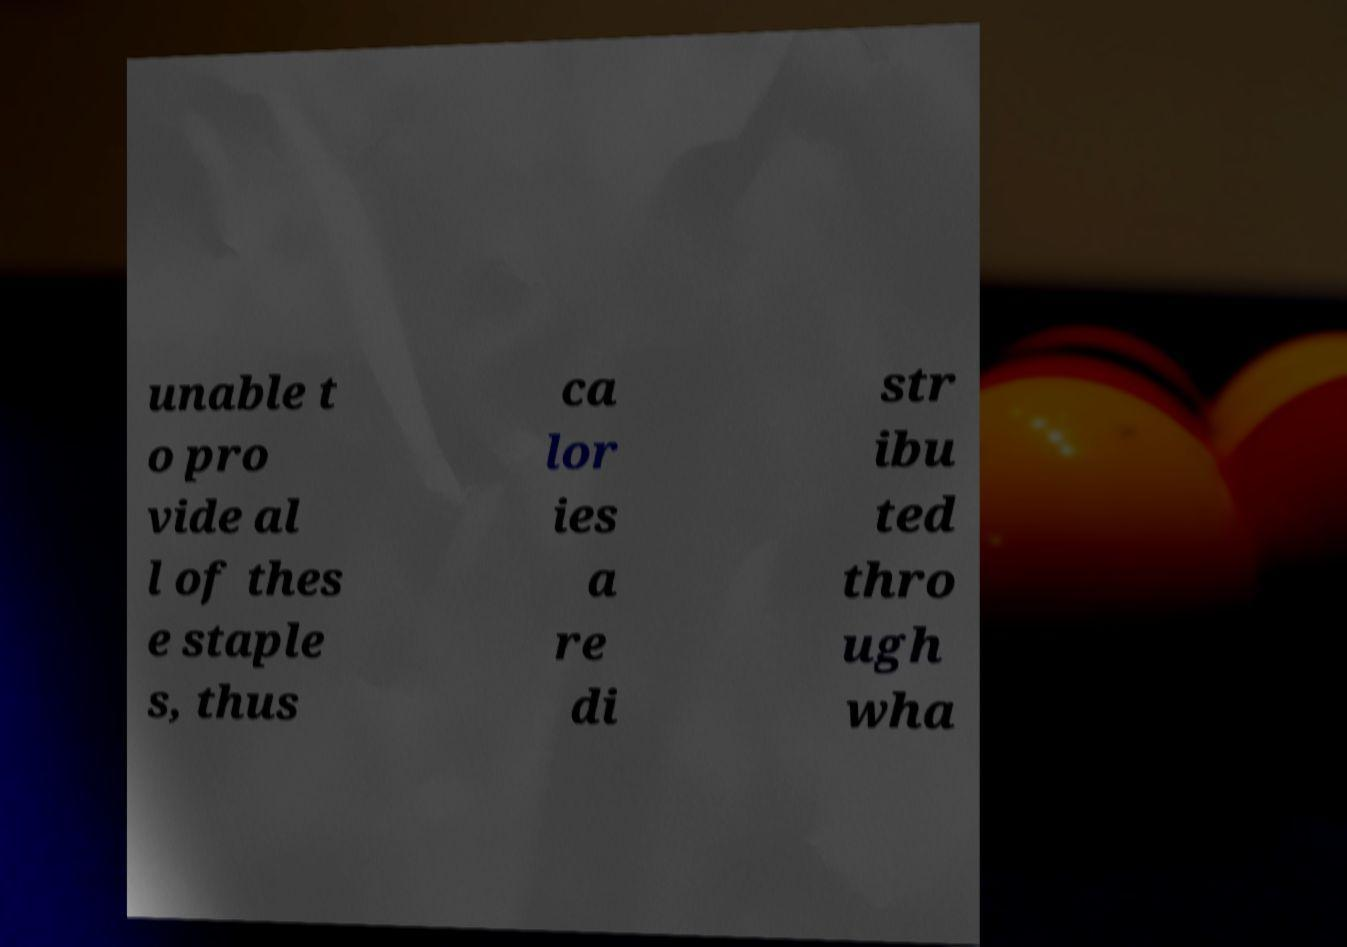Could you assist in decoding the text presented in this image and type it out clearly? unable t o pro vide al l of thes e staple s, thus ca lor ies a re di str ibu ted thro ugh wha 